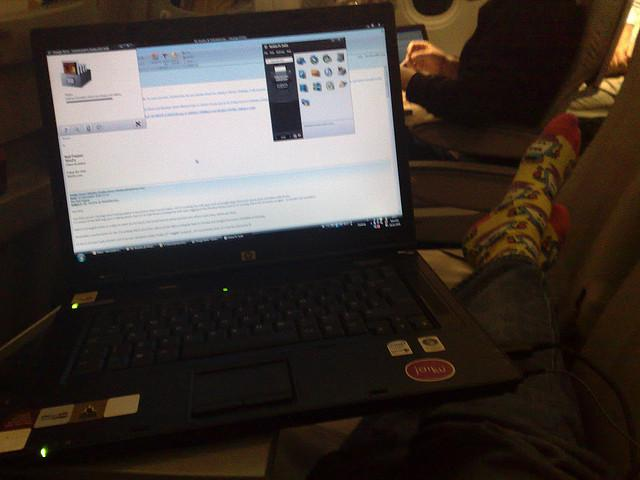This person is operating their laptop in what form of transportation? airplane 